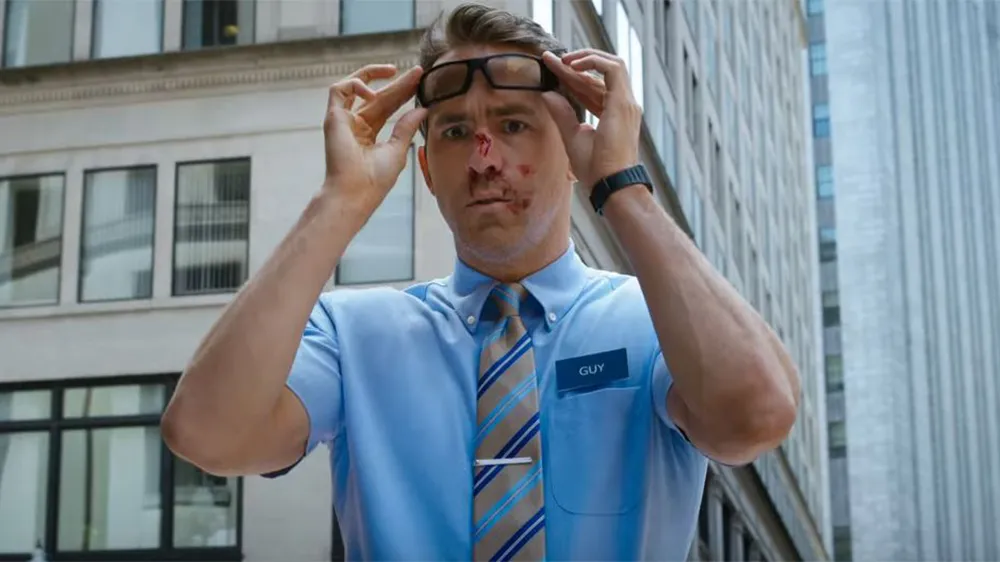What could have caused the injury to the man's nose? It appears he might have been involved in a minor accident or mishap, possibly related to a fast-paced or chaotic event given his surprised expression. Could there be any symbolic meaning behind his uniform and the setting? The uniform, especially with its name tag, typically suggests a theme of everyday heroism or a common man placed in an extraordinary situation. The urban backdrop could symbolize a bustling, challenging environment that tests the character. 